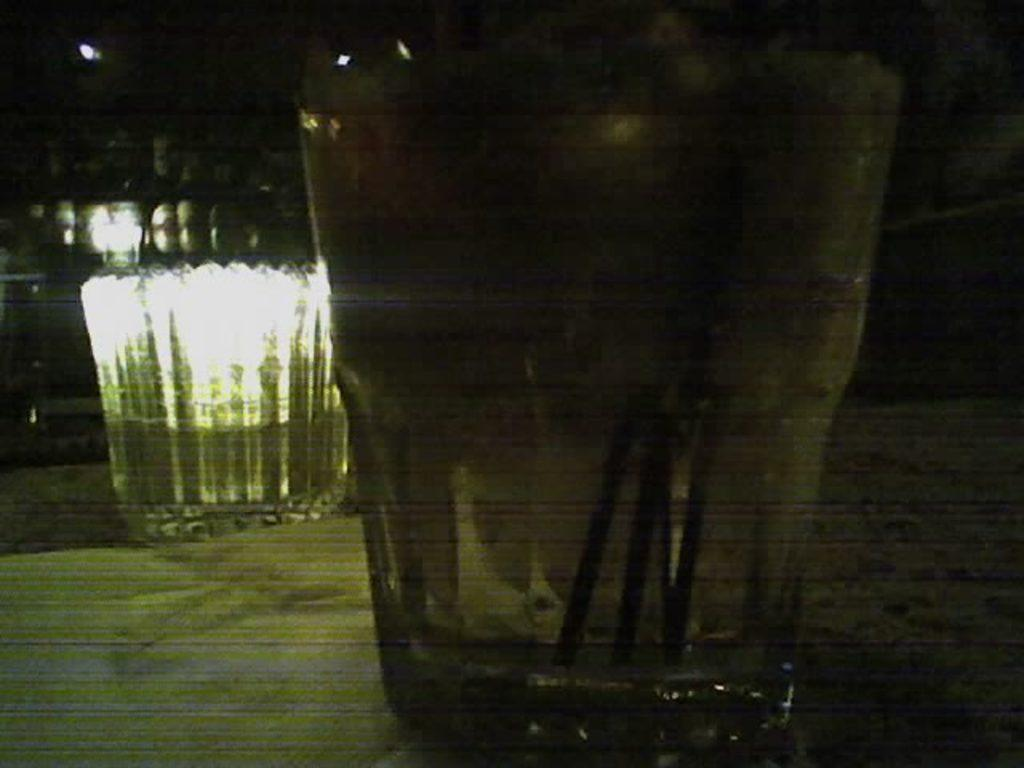What is in the center of the image? There is a glass in the middle of the image. What is inside the glass? The glass contains water. Can you describe another glass in the image? There is another glass in the background of the image. What type of wren can be seen sitting on the edge of the glass in the image? There is no wren present in the image; it only features glasses containing water. 